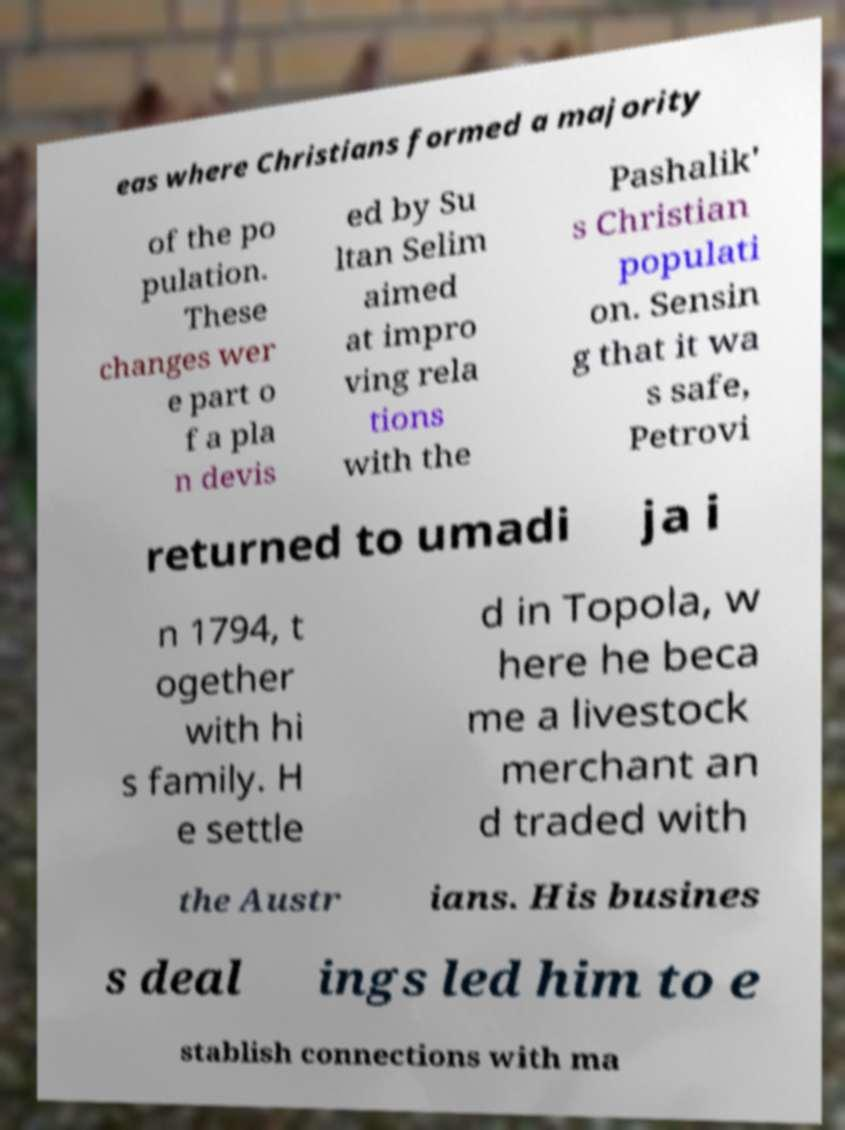Can you read and provide the text displayed in the image?This photo seems to have some interesting text. Can you extract and type it out for me? eas where Christians formed a majority of the po pulation. These changes wer e part o f a pla n devis ed by Su ltan Selim aimed at impro ving rela tions with the Pashalik' s Christian populati on. Sensin g that it wa s safe, Petrovi returned to umadi ja i n 1794, t ogether with hi s family. H e settle d in Topola, w here he beca me a livestock merchant an d traded with the Austr ians. His busines s deal ings led him to e stablish connections with ma 